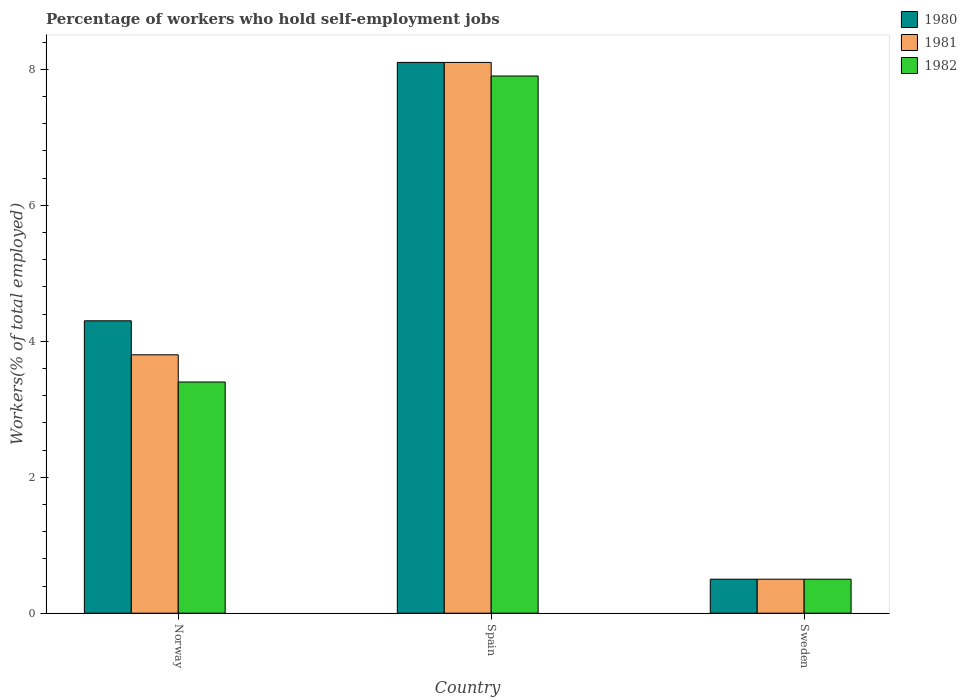How many different coloured bars are there?
Your answer should be compact. 3. Are the number of bars per tick equal to the number of legend labels?
Provide a succinct answer. Yes. How many bars are there on the 1st tick from the left?
Provide a succinct answer. 3. How many bars are there on the 2nd tick from the right?
Provide a short and direct response. 3. What is the label of the 3rd group of bars from the left?
Offer a terse response. Sweden. What is the percentage of self-employed workers in 1982 in Spain?
Your response must be concise. 7.9. Across all countries, what is the maximum percentage of self-employed workers in 1981?
Your answer should be very brief. 8.1. Across all countries, what is the minimum percentage of self-employed workers in 1980?
Keep it short and to the point. 0.5. In which country was the percentage of self-employed workers in 1980 minimum?
Provide a short and direct response. Sweden. What is the total percentage of self-employed workers in 1981 in the graph?
Your response must be concise. 12.4. What is the difference between the percentage of self-employed workers in 1981 in Spain and that in Sweden?
Provide a succinct answer. 7.6. What is the difference between the percentage of self-employed workers in 1980 in Norway and the percentage of self-employed workers in 1982 in Spain?
Your response must be concise. -3.6. What is the average percentage of self-employed workers in 1982 per country?
Your response must be concise. 3.93. In how many countries, is the percentage of self-employed workers in 1982 greater than 2.4 %?
Keep it short and to the point. 2. What is the ratio of the percentage of self-employed workers in 1981 in Spain to that in Sweden?
Make the answer very short. 16.2. Is the percentage of self-employed workers in 1980 in Norway less than that in Spain?
Offer a terse response. Yes. What is the difference between the highest and the second highest percentage of self-employed workers in 1981?
Make the answer very short. 7.6. What is the difference between the highest and the lowest percentage of self-employed workers in 1982?
Offer a terse response. 7.4. Is the sum of the percentage of self-employed workers in 1982 in Norway and Spain greater than the maximum percentage of self-employed workers in 1980 across all countries?
Make the answer very short. Yes. What does the 2nd bar from the left in Norway represents?
Offer a very short reply. 1981. Are all the bars in the graph horizontal?
Your response must be concise. No. How many countries are there in the graph?
Provide a short and direct response. 3. Are the values on the major ticks of Y-axis written in scientific E-notation?
Provide a short and direct response. No. Does the graph contain any zero values?
Give a very brief answer. No. How many legend labels are there?
Make the answer very short. 3. How are the legend labels stacked?
Your response must be concise. Vertical. What is the title of the graph?
Give a very brief answer. Percentage of workers who hold self-employment jobs. What is the label or title of the X-axis?
Keep it short and to the point. Country. What is the label or title of the Y-axis?
Your answer should be compact. Workers(% of total employed). What is the Workers(% of total employed) in 1980 in Norway?
Provide a succinct answer. 4.3. What is the Workers(% of total employed) of 1981 in Norway?
Your answer should be very brief. 3.8. What is the Workers(% of total employed) of 1982 in Norway?
Provide a succinct answer. 3.4. What is the Workers(% of total employed) of 1980 in Spain?
Provide a short and direct response. 8.1. What is the Workers(% of total employed) in 1981 in Spain?
Offer a terse response. 8.1. What is the Workers(% of total employed) of 1982 in Spain?
Offer a very short reply. 7.9. What is the Workers(% of total employed) of 1981 in Sweden?
Make the answer very short. 0.5. What is the Workers(% of total employed) of 1982 in Sweden?
Ensure brevity in your answer.  0.5. Across all countries, what is the maximum Workers(% of total employed) in 1980?
Provide a short and direct response. 8.1. Across all countries, what is the maximum Workers(% of total employed) in 1981?
Give a very brief answer. 8.1. Across all countries, what is the maximum Workers(% of total employed) of 1982?
Ensure brevity in your answer.  7.9. What is the total Workers(% of total employed) of 1981 in the graph?
Offer a terse response. 12.4. What is the total Workers(% of total employed) of 1982 in the graph?
Make the answer very short. 11.8. What is the difference between the Workers(% of total employed) in 1980 in Norway and that in Spain?
Offer a very short reply. -3.8. What is the difference between the Workers(% of total employed) of 1981 in Norway and that in Spain?
Offer a very short reply. -4.3. What is the difference between the Workers(% of total employed) in 1982 in Norway and that in Spain?
Ensure brevity in your answer.  -4.5. What is the difference between the Workers(% of total employed) in 1981 in Norway and that in Sweden?
Your response must be concise. 3.3. What is the difference between the Workers(% of total employed) of 1980 in Spain and that in Sweden?
Provide a succinct answer. 7.6. What is the difference between the Workers(% of total employed) in 1982 in Spain and that in Sweden?
Ensure brevity in your answer.  7.4. What is the difference between the Workers(% of total employed) in 1980 in Norway and the Workers(% of total employed) in 1981 in Spain?
Ensure brevity in your answer.  -3.8. What is the difference between the Workers(% of total employed) in 1981 in Norway and the Workers(% of total employed) in 1982 in Spain?
Keep it short and to the point. -4.1. What is the difference between the Workers(% of total employed) in 1980 in Norway and the Workers(% of total employed) in 1981 in Sweden?
Provide a succinct answer. 3.8. What is the difference between the Workers(% of total employed) in 1981 in Norway and the Workers(% of total employed) in 1982 in Sweden?
Offer a terse response. 3.3. What is the difference between the Workers(% of total employed) in 1980 in Spain and the Workers(% of total employed) in 1981 in Sweden?
Offer a terse response. 7.6. What is the difference between the Workers(% of total employed) of 1980 in Spain and the Workers(% of total employed) of 1982 in Sweden?
Make the answer very short. 7.6. What is the difference between the Workers(% of total employed) of 1981 in Spain and the Workers(% of total employed) of 1982 in Sweden?
Your response must be concise. 7.6. What is the average Workers(% of total employed) of 1980 per country?
Make the answer very short. 4.3. What is the average Workers(% of total employed) in 1981 per country?
Give a very brief answer. 4.13. What is the average Workers(% of total employed) in 1982 per country?
Your response must be concise. 3.93. What is the difference between the Workers(% of total employed) in 1980 and Workers(% of total employed) in 1981 in Norway?
Give a very brief answer. 0.5. What is the difference between the Workers(% of total employed) of 1980 and Workers(% of total employed) of 1982 in Norway?
Offer a very short reply. 0.9. What is the difference between the Workers(% of total employed) of 1980 and Workers(% of total employed) of 1981 in Spain?
Offer a very short reply. 0. What is the difference between the Workers(% of total employed) of 1980 and Workers(% of total employed) of 1982 in Spain?
Ensure brevity in your answer.  0.2. What is the difference between the Workers(% of total employed) of 1981 and Workers(% of total employed) of 1982 in Spain?
Provide a succinct answer. 0.2. What is the difference between the Workers(% of total employed) in 1980 and Workers(% of total employed) in 1981 in Sweden?
Ensure brevity in your answer.  0. What is the ratio of the Workers(% of total employed) of 1980 in Norway to that in Spain?
Your answer should be very brief. 0.53. What is the ratio of the Workers(% of total employed) of 1981 in Norway to that in Spain?
Your response must be concise. 0.47. What is the ratio of the Workers(% of total employed) of 1982 in Norway to that in Spain?
Provide a succinct answer. 0.43. What is the ratio of the Workers(% of total employed) of 1980 in Norway to that in Sweden?
Your answer should be very brief. 8.6. What is the ratio of the Workers(% of total employed) in 1980 in Spain to that in Sweden?
Give a very brief answer. 16.2. What is the difference between the highest and the second highest Workers(% of total employed) of 1980?
Offer a very short reply. 3.8. What is the difference between the highest and the second highest Workers(% of total employed) of 1981?
Your response must be concise. 4.3. What is the difference between the highest and the lowest Workers(% of total employed) of 1980?
Provide a succinct answer. 7.6. 